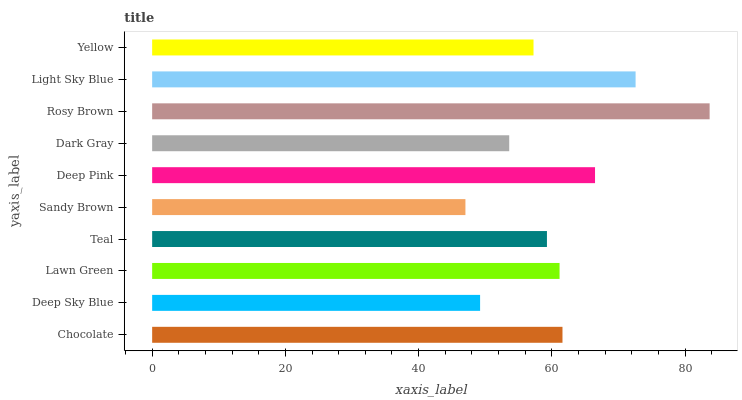Is Sandy Brown the minimum?
Answer yes or no. Yes. Is Rosy Brown the maximum?
Answer yes or no. Yes. Is Deep Sky Blue the minimum?
Answer yes or no. No. Is Deep Sky Blue the maximum?
Answer yes or no. No. Is Chocolate greater than Deep Sky Blue?
Answer yes or no. Yes. Is Deep Sky Blue less than Chocolate?
Answer yes or no. Yes. Is Deep Sky Blue greater than Chocolate?
Answer yes or no. No. Is Chocolate less than Deep Sky Blue?
Answer yes or no. No. Is Lawn Green the high median?
Answer yes or no. Yes. Is Teal the low median?
Answer yes or no. Yes. Is Deep Pink the high median?
Answer yes or no. No. Is Chocolate the low median?
Answer yes or no. No. 